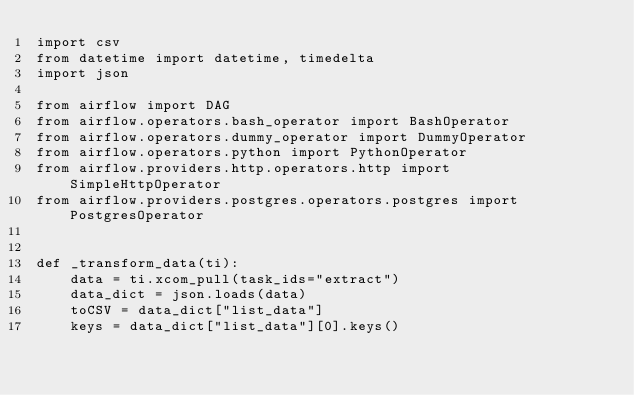<code> <loc_0><loc_0><loc_500><loc_500><_Python_>import csv
from datetime import datetime, timedelta
import json

from airflow import DAG
from airflow.operators.bash_operator import BashOperator
from airflow.operators.dummy_operator import DummyOperator
from airflow.operators.python import PythonOperator
from airflow.providers.http.operators.http import SimpleHttpOperator
from airflow.providers.postgres.operators.postgres import PostgresOperator


def _transform_data(ti):
    data = ti.xcom_pull(task_ids="extract")
    data_dict = json.loads(data)
    toCSV = data_dict["list_data"]
    keys = data_dict["list_data"][0].keys()</code> 